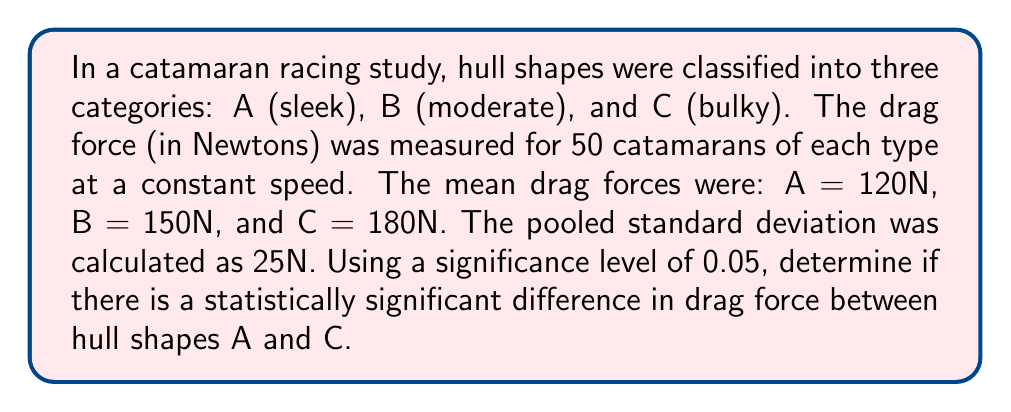Provide a solution to this math problem. To determine if there's a statistically significant difference between hull shapes A and C, we'll use a two-sample t-test. The steps are as follows:

1. State the null and alternative hypotheses:
   $H_0: \mu_A = \mu_C$ (no difference in mean drag force)
   $H_a: \mu_A \neq \mu_C$ (there is a difference in mean drag force)

2. Calculate the t-statistic:
   $$t = \frac{\bar{X}_A - \bar{X}_C}{s_p\sqrt{\frac{2}{n}}}$$
   where $\bar{X}_A$ and $\bar{X}_C$ are the sample means, $s_p$ is the pooled standard deviation, and $n$ is the sample size for each group.

3. Plug in the values:
   $$t = \frac{120 - 180}{25\sqrt{\frac{2}{50}}} = \frac{-60}{25 \cdot 0.2} = -12$$

4. Determine the degrees of freedom:
   $df = n_A + n_C - 2 = 50 + 50 - 2 = 98$

5. Find the critical t-value for a two-tailed test with $\alpha = 0.05$ and $df = 98$:
   $t_{critical} = \pm 1.984$ (from t-distribution table)

6. Compare the calculated t-statistic to the critical value:
   $|-12| > 1.984$

7. Since the absolute value of our calculated t-statistic is greater than the critical value, we reject the null hypothesis.

8. Calculate the p-value:
   The p-value for $t = -12$ with $df = 98$ is extremely small $(p < 0.0001)$, which is less than our significance level of 0.05.
Answer: Reject $H_0$; statistically significant difference $(p < 0.0001)$. 